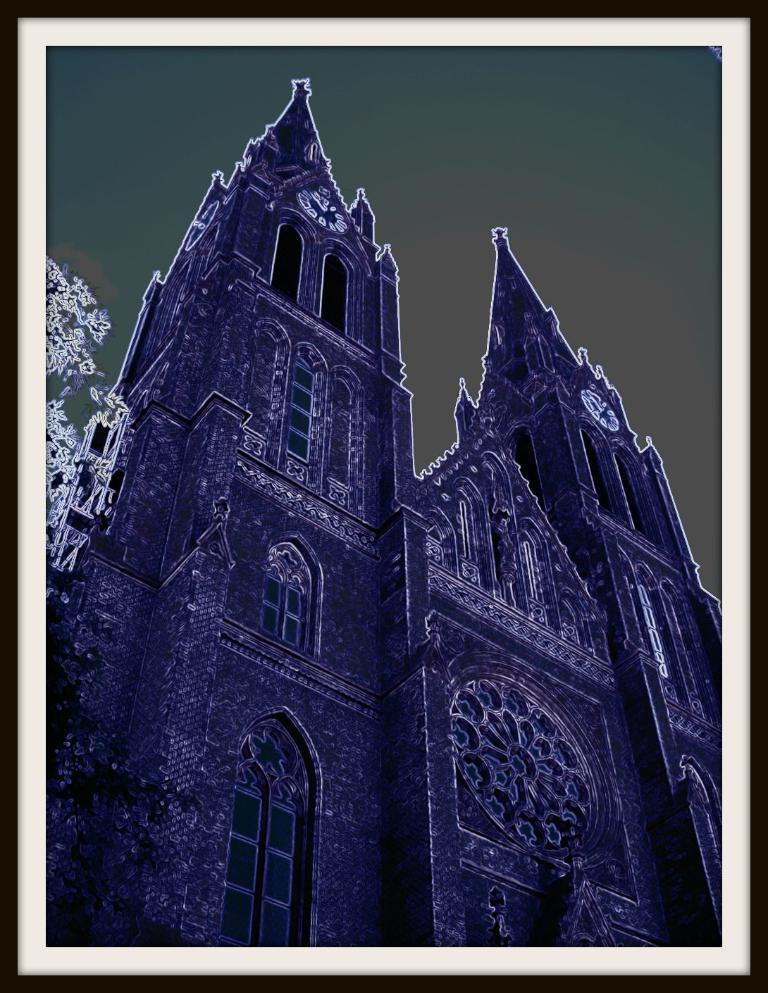What is the main subject in the foreground of the image? There is a building in the foreground of the image. What can be seen on the left side of the image? There is a tree on the left side of the image. What is visible at the top of the image? The sky is visible at the top of the image. What type of disease is affecting the tree on the left side of the image? There is no indication of any disease affecting the tree in the image; it appears to be a healthy tree. 